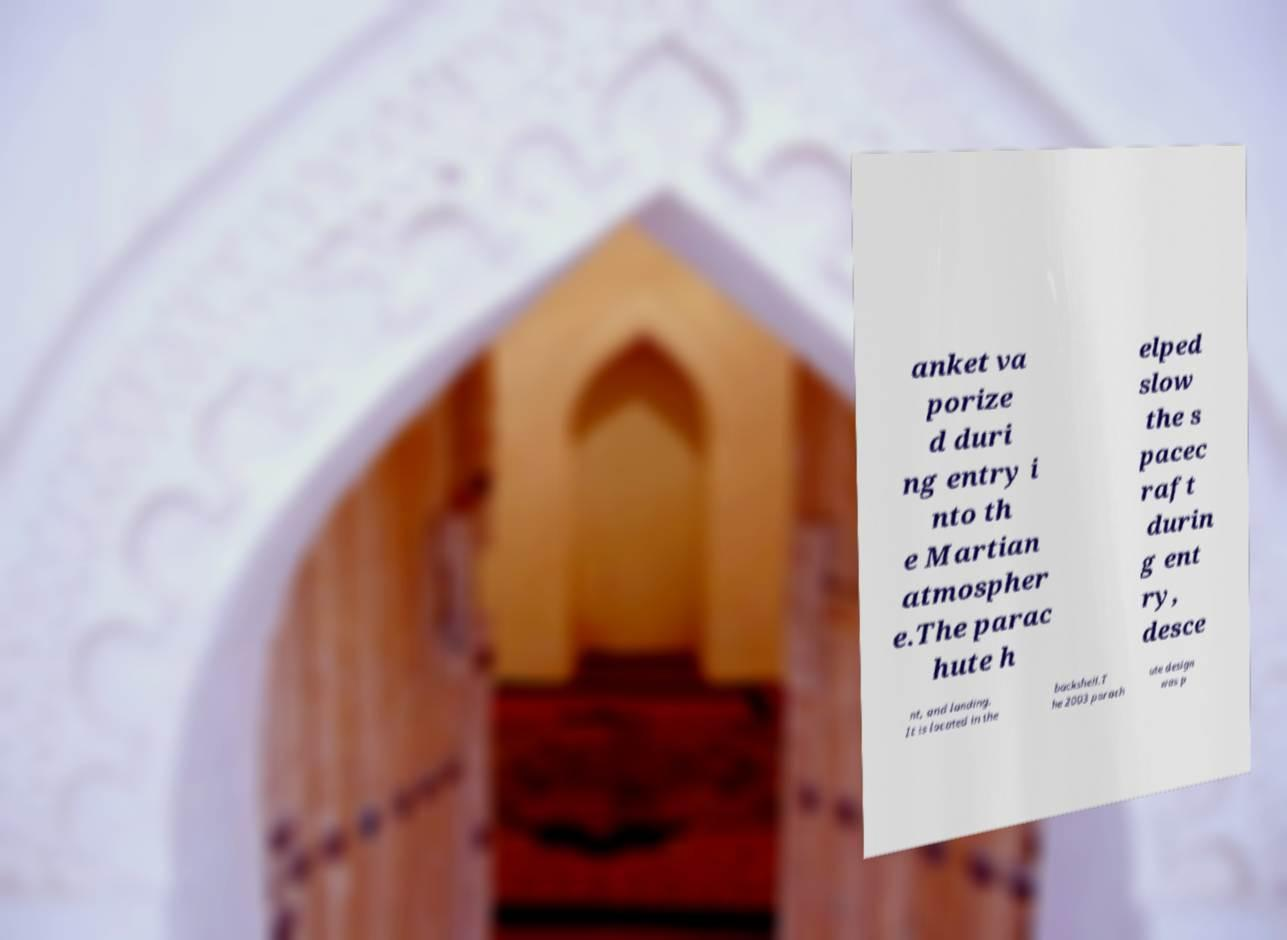For documentation purposes, I need the text within this image transcribed. Could you provide that? anket va porize d duri ng entry i nto th e Martian atmospher e.The parac hute h elped slow the s pacec raft durin g ent ry, desce nt, and landing. It is located in the backshell.T he 2003 parach ute design was p 